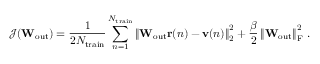Convert formula to latex. <formula><loc_0><loc_0><loc_500><loc_500>\mathcal { J } ( W _ { o u t } ) = \frac { 1 } { 2 N _ { t r a i n } } \sum _ { n = 1 } ^ { N _ { t r a i n } } \left \| W _ { o u t } r ( n ) - v ( n ) \right \| _ { 2 } ^ { 2 } + \frac { \beta } { 2 } \left \| W _ { o u t } \right \| _ { F } ^ { 2 } \, .</formula> 